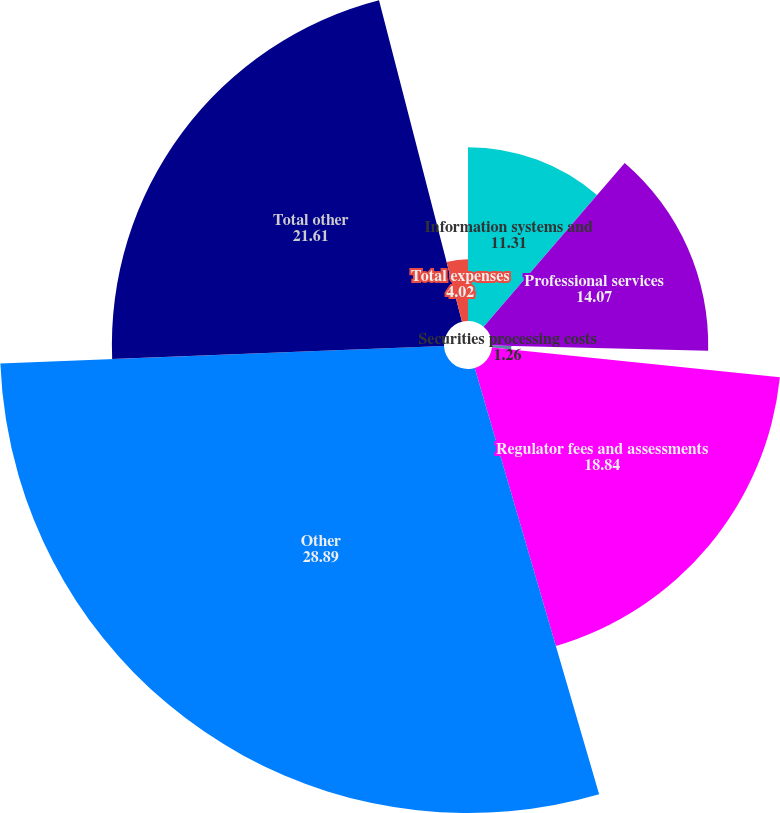Convert chart. <chart><loc_0><loc_0><loc_500><loc_500><pie_chart><fcel>Information systems and<fcel>Professional services<fcel>Securities processing costs<fcel>Regulator fees and assessments<fcel>Other<fcel>Total other<fcel>Total expenses<nl><fcel>11.31%<fcel>14.07%<fcel>1.26%<fcel>18.84%<fcel>28.89%<fcel>21.61%<fcel>4.02%<nl></chart> 